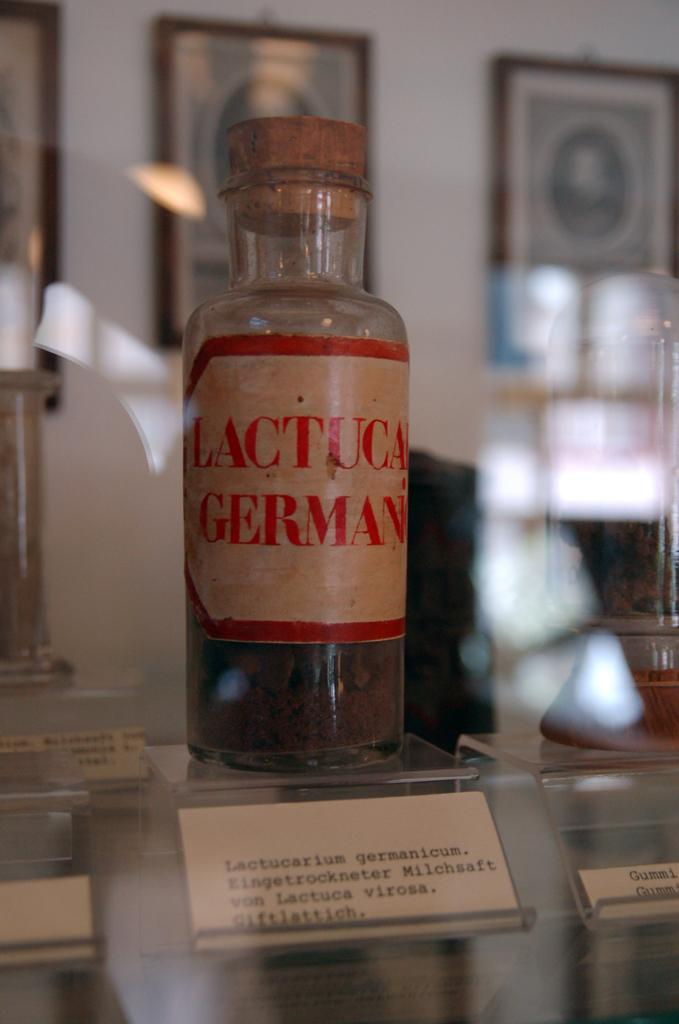<image>
Provide a brief description of the given image. A old bottle of lactuca germanicum sits in a display case. 